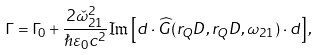Convert formula to latex. <formula><loc_0><loc_0><loc_500><loc_500>\Gamma = \Gamma _ { 0 } + \frac { 2 \check { \omega } _ { 2 1 } ^ { 2 } } { \hslash \varepsilon _ { 0 } c ^ { 2 } } \Im \left [ d \cdot \widehat { G } ( r _ { Q } D , r _ { Q } D , \omega _ { 2 1 } ) \cdot d \right ] ,</formula> 